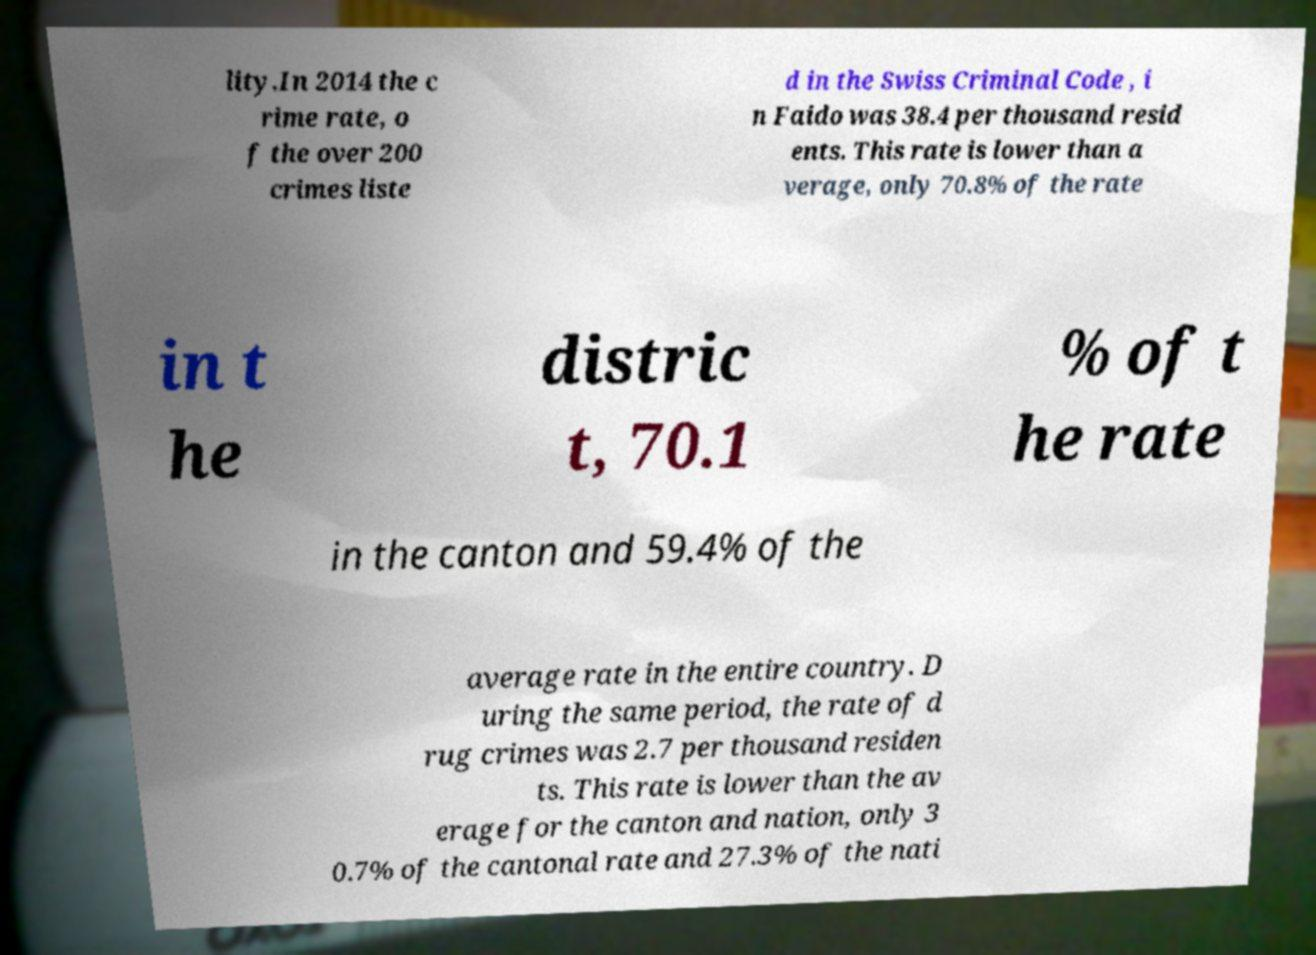Can you read and provide the text displayed in the image?This photo seems to have some interesting text. Can you extract and type it out for me? lity.In 2014 the c rime rate, o f the over 200 crimes liste d in the Swiss Criminal Code , i n Faido was 38.4 per thousand resid ents. This rate is lower than a verage, only 70.8% of the rate in t he distric t, 70.1 % of t he rate in the canton and 59.4% of the average rate in the entire country. D uring the same period, the rate of d rug crimes was 2.7 per thousand residen ts. This rate is lower than the av erage for the canton and nation, only 3 0.7% of the cantonal rate and 27.3% of the nati 